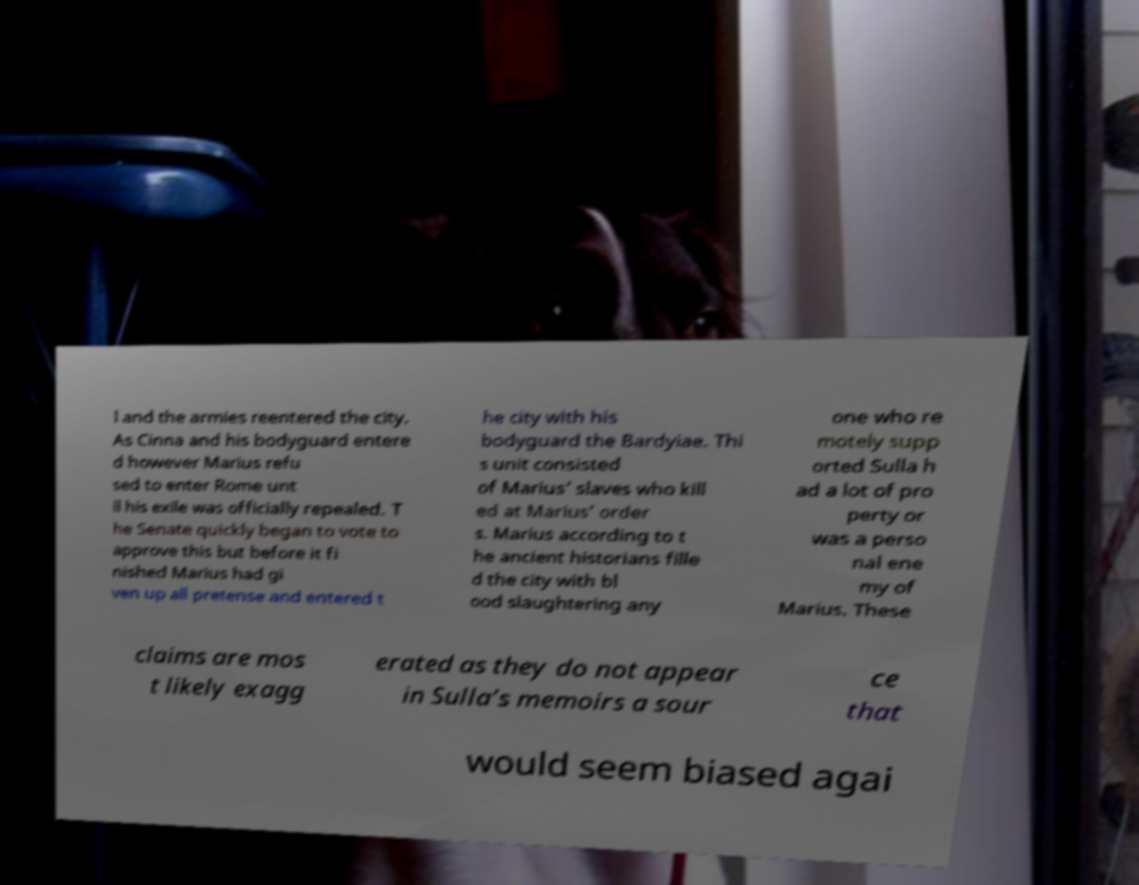There's text embedded in this image that I need extracted. Can you transcribe it verbatim? l and the armies reentered the city. As Cinna and his bodyguard entere d however Marius refu sed to enter Rome unt il his exile was officially repealed. T he Senate quickly began to vote to approve this but before it fi nished Marius had gi ven up all pretense and entered t he city with his bodyguard the Bardyiae. Thi s unit consisted of Marius’ slaves who kill ed at Marius’ order s. Marius according to t he ancient historians fille d the city with bl ood slaughtering any one who re motely supp orted Sulla h ad a lot of pro perty or was a perso nal ene my of Marius. These claims are mos t likely exagg erated as they do not appear in Sulla’s memoirs a sour ce that would seem biased agai 